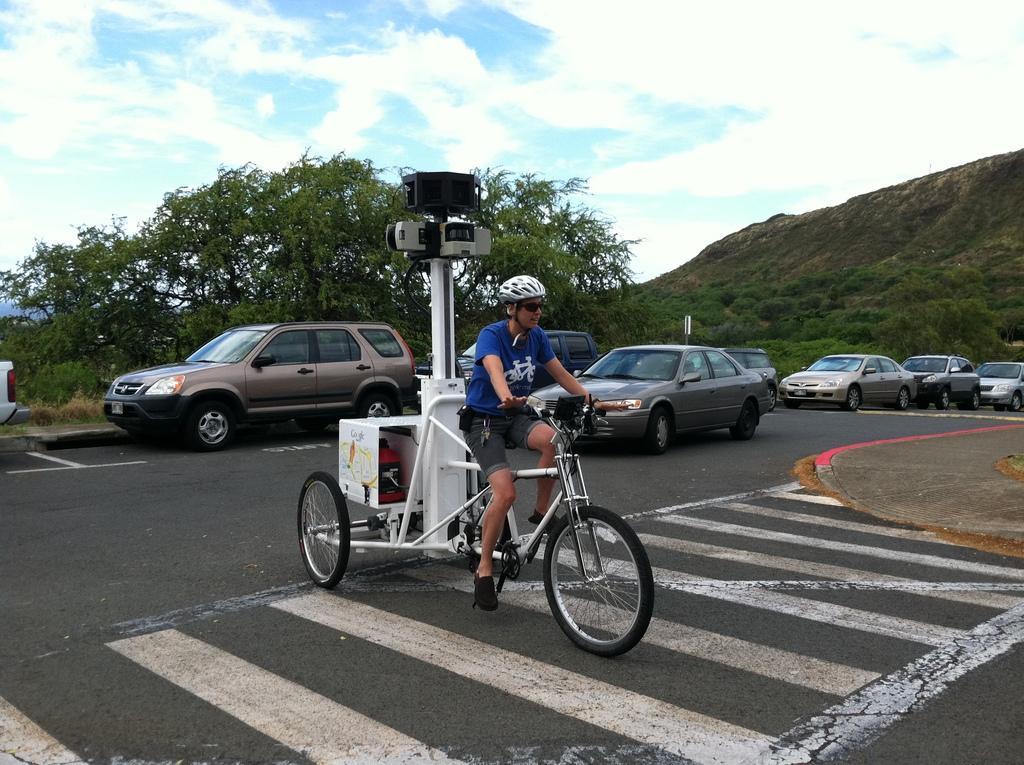How would you summarize this image in a sentence or two? In the middle of the image we can see a man, he is riding tricycle and we can see cameras, in the background we can see cars, trees and clouds. 